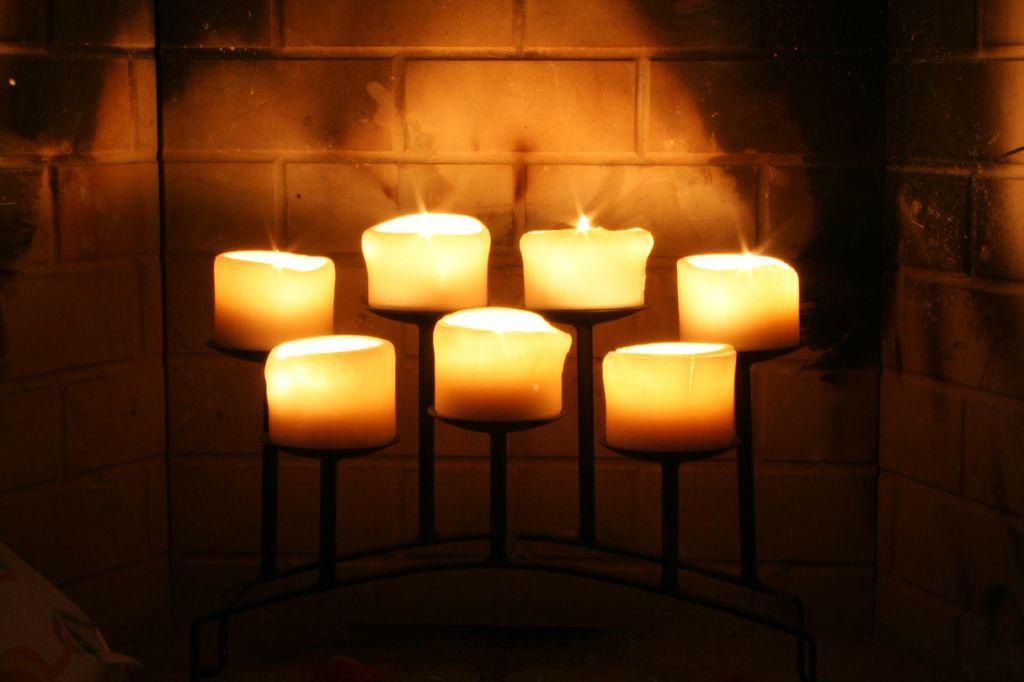Describe this image in one or two sentences. In this picture we can see there are candles on the stands. Behind the candles, there's a wall. 